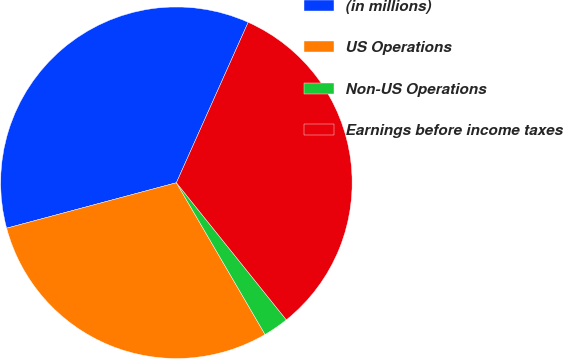<chart> <loc_0><loc_0><loc_500><loc_500><pie_chart><fcel>(in millions)<fcel>US Operations<fcel>Non-US Operations<fcel>Earnings before income taxes<nl><fcel>35.86%<fcel>29.25%<fcel>2.34%<fcel>32.55%<nl></chart> 